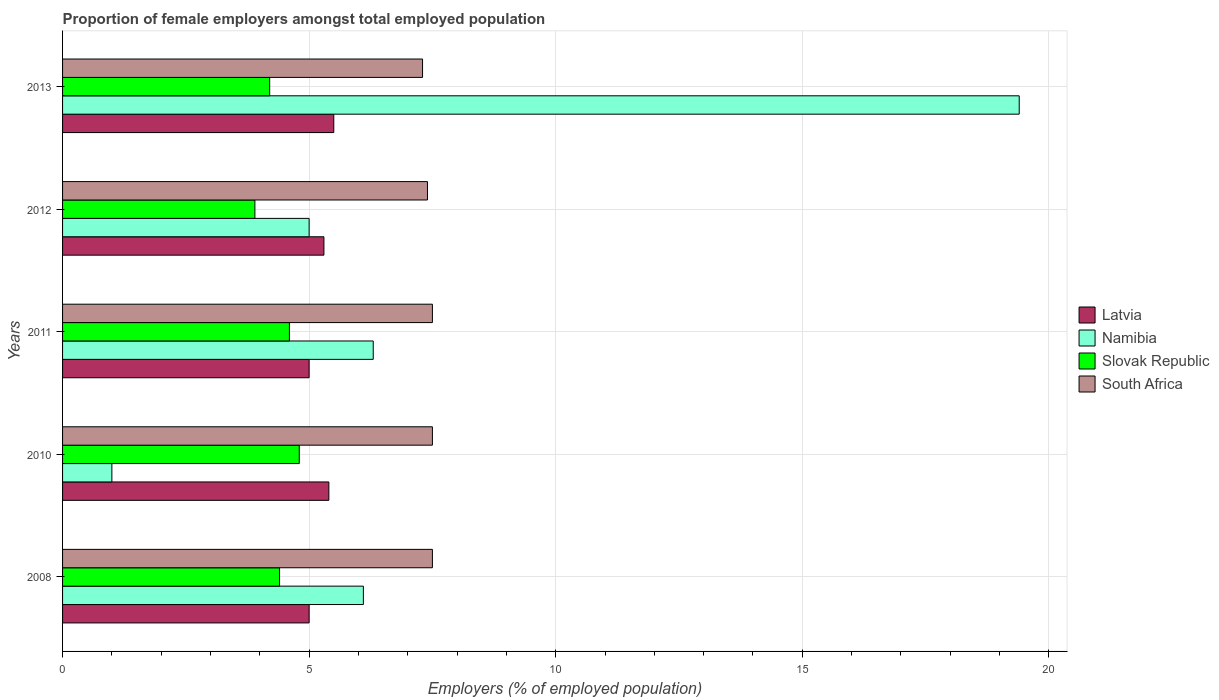How many groups of bars are there?
Provide a succinct answer. 5. Are the number of bars on each tick of the Y-axis equal?
Make the answer very short. Yes. In how many cases, is the number of bars for a given year not equal to the number of legend labels?
Your answer should be very brief. 0. Across all years, what is the minimum proportion of female employers in South Africa?
Provide a short and direct response. 7.3. In which year was the proportion of female employers in Slovak Republic maximum?
Your response must be concise. 2010. In which year was the proportion of female employers in South Africa minimum?
Offer a very short reply. 2013. What is the total proportion of female employers in Namibia in the graph?
Keep it short and to the point. 37.8. What is the difference between the proportion of female employers in Latvia in 2008 and that in 2012?
Your answer should be compact. -0.3. What is the difference between the proportion of female employers in Namibia in 2008 and the proportion of female employers in Slovak Republic in 2012?
Your answer should be very brief. 2.2. What is the average proportion of female employers in Namibia per year?
Offer a very short reply. 7.56. In the year 2010, what is the difference between the proportion of female employers in Slovak Republic and proportion of female employers in South Africa?
Provide a succinct answer. -2.7. What is the ratio of the proportion of female employers in South Africa in 2010 to that in 2013?
Offer a very short reply. 1.03. Is the proportion of female employers in South Africa in 2008 less than that in 2013?
Offer a terse response. No. What is the difference between the highest and the second highest proportion of female employers in Namibia?
Your answer should be very brief. 13.1. What is the difference between the highest and the lowest proportion of female employers in South Africa?
Your answer should be very brief. 0.2. In how many years, is the proportion of female employers in Slovak Republic greater than the average proportion of female employers in Slovak Republic taken over all years?
Your answer should be compact. 3. Is the sum of the proportion of female employers in Slovak Republic in 2008 and 2013 greater than the maximum proportion of female employers in Namibia across all years?
Your answer should be very brief. No. Is it the case that in every year, the sum of the proportion of female employers in Slovak Republic and proportion of female employers in Namibia is greater than the sum of proportion of female employers in South Africa and proportion of female employers in Latvia?
Make the answer very short. No. What does the 1st bar from the top in 2010 represents?
Provide a short and direct response. South Africa. What does the 3rd bar from the bottom in 2012 represents?
Your answer should be compact. Slovak Republic. Is it the case that in every year, the sum of the proportion of female employers in South Africa and proportion of female employers in Latvia is greater than the proportion of female employers in Namibia?
Your response must be concise. No. Are all the bars in the graph horizontal?
Keep it short and to the point. Yes. How many years are there in the graph?
Your answer should be compact. 5. What is the difference between two consecutive major ticks on the X-axis?
Your answer should be compact. 5. Does the graph contain any zero values?
Offer a terse response. No. How are the legend labels stacked?
Your answer should be very brief. Vertical. What is the title of the graph?
Give a very brief answer. Proportion of female employers amongst total employed population. Does "Gabon" appear as one of the legend labels in the graph?
Provide a succinct answer. No. What is the label or title of the X-axis?
Provide a succinct answer. Employers (% of employed population). What is the label or title of the Y-axis?
Provide a short and direct response. Years. What is the Employers (% of employed population) of Latvia in 2008?
Offer a terse response. 5. What is the Employers (% of employed population) in Namibia in 2008?
Your answer should be very brief. 6.1. What is the Employers (% of employed population) in Slovak Republic in 2008?
Provide a succinct answer. 4.4. What is the Employers (% of employed population) in South Africa in 2008?
Provide a short and direct response. 7.5. What is the Employers (% of employed population) in Latvia in 2010?
Your response must be concise. 5.4. What is the Employers (% of employed population) in Slovak Republic in 2010?
Offer a very short reply. 4.8. What is the Employers (% of employed population) in Namibia in 2011?
Your answer should be compact. 6.3. What is the Employers (% of employed population) of Slovak Republic in 2011?
Provide a succinct answer. 4.6. What is the Employers (% of employed population) in South Africa in 2011?
Ensure brevity in your answer.  7.5. What is the Employers (% of employed population) of Latvia in 2012?
Offer a very short reply. 5.3. What is the Employers (% of employed population) in Namibia in 2012?
Provide a succinct answer. 5. What is the Employers (% of employed population) of Slovak Republic in 2012?
Provide a short and direct response. 3.9. What is the Employers (% of employed population) in South Africa in 2012?
Make the answer very short. 7.4. What is the Employers (% of employed population) of Latvia in 2013?
Your response must be concise. 5.5. What is the Employers (% of employed population) in Namibia in 2013?
Your answer should be very brief. 19.4. What is the Employers (% of employed population) in Slovak Republic in 2013?
Provide a succinct answer. 4.2. What is the Employers (% of employed population) of South Africa in 2013?
Make the answer very short. 7.3. Across all years, what is the maximum Employers (% of employed population) of Latvia?
Offer a terse response. 5.5. Across all years, what is the maximum Employers (% of employed population) in Namibia?
Offer a terse response. 19.4. Across all years, what is the maximum Employers (% of employed population) in Slovak Republic?
Give a very brief answer. 4.8. Across all years, what is the minimum Employers (% of employed population) in Slovak Republic?
Ensure brevity in your answer.  3.9. Across all years, what is the minimum Employers (% of employed population) of South Africa?
Your answer should be compact. 7.3. What is the total Employers (% of employed population) of Latvia in the graph?
Give a very brief answer. 26.2. What is the total Employers (% of employed population) of Namibia in the graph?
Provide a succinct answer. 37.8. What is the total Employers (% of employed population) of Slovak Republic in the graph?
Your answer should be compact. 21.9. What is the total Employers (% of employed population) of South Africa in the graph?
Give a very brief answer. 37.2. What is the difference between the Employers (% of employed population) in Latvia in 2008 and that in 2010?
Give a very brief answer. -0.4. What is the difference between the Employers (% of employed population) of Namibia in 2008 and that in 2011?
Provide a short and direct response. -0.2. What is the difference between the Employers (% of employed population) of Slovak Republic in 2008 and that in 2011?
Provide a succinct answer. -0.2. What is the difference between the Employers (% of employed population) in South Africa in 2008 and that in 2011?
Your response must be concise. 0. What is the difference between the Employers (% of employed population) in Latvia in 2008 and that in 2012?
Keep it short and to the point. -0.3. What is the difference between the Employers (% of employed population) of Namibia in 2008 and that in 2012?
Keep it short and to the point. 1.1. What is the difference between the Employers (% of employed population) of Slovak Republic in 2008 and that in 2012?
Offer a very short reply. 0.5. What is the difference between the Employers (% of employed population) in South Africa in 2008 and that in 2012?
Offer a terse response. 0.1. What is the difference between the Employers (% of employed population) in Namibia in 2008 and that in 2013?
Your answer should be very brief. -13.3. What is the difference between the Employers (% of employed population) in South Africa in 2008 and that in 2013?
Give a very brief answer. 0.2. What is the difference between the Employers (% of employed population) of Latvia in 2010 and that in 2011?
Your answer should be compact. 0.4. What is the difference between the Employers (% of employed population) in Namibia in 2010 and that in 2011?
Give a very brief answer. -5.3. What is the difference between the Employers (% of employed population) in Slovak Republic in 2010 and that in 2011?
Offer a terse response. 0.2. What is the difference between the Employers (% of employed population) of South Africa in 2010 and that in 2011?
Offer a terse response. 0. What is the difference between the Employers (% of employed population) of Namibia in 2010 and that in 2012?
Your answer should be compact. -4. What is the difference between the Employers (% of employed population) in Slovak Republic in 2010 and that in 2012?
Provide a succinct answer. 0.9. What is the difference between the Employers (% of employed population) of South Africa in 2010 and that in 2012?
Provide a short and direct response. 0.1. What is the difference between the Employers (% of employed population) in Latvia in 2010 and that in 2013?
Ensure brevity in your answer.  -0.1. What is the difference between the Employers (% of employed population) in Namibia in 2010 and that in 2013?
Make the answer very short. -18.4. What is the difference between the Employers (% of employed population) of Slovak Republic in 2010 and that in 2013?
Your response must be concise. 0.6. What is the difference between the Employers (% of employed population) in Namibia in 2011 and that in 2012?
Offer a very short reply. 1.3. What is the difference between the Employers (% of employed population) in Slovak Republic in 2011 and that in 2013?
Make the answer very short. 0.4. What is the difference between the Employers (% of employed population) of Latvia in 2012 and that in 2013?
Your answer should be very brief. -0.2. What is the difference between the Employers (% of employed population) of Namibia in 2012 and that in 2013?
Your answer should be very brief. -14.4. What is the difference between the Employers (% of employed population) of Latvia in 2008 and the Employers (% of employed population) of Slovak Republic in 2010?
Your response must be concise. 0.2. What is the difference between the Employers (% of employed population) in Namibia in 2008 and the Employers (% of employed population) in Slovak Republic in 2010?
Make the answer very short. 1.3. What is the difference between the Employers (% of employed population) in Namibia in 2008 and the Employers (% of employed population) in South Africa in 2010?
Offer a very short reply. -1.4. What is the difference between the Employers (% of employed population) of Latvia in 2008 and the Employers (% of employed population) of Namibia in 2011?
Your answer should be very brief. -1.3. What is the difference between the Employers (% of employed population) in Latvia in 2008 and the Employers (% of employed population) in South Africa in 2011?
Your answer should be very brief. -2.5. What is the difference between the Employers (% of employed population) of Namibia in 2008 and the Employers (% of employed population) of Slovak Republic in 2011?
Offer a terse response. 1.5. What is the difference between the Employers (% of employed population) in Namibia in 2008 and the Employers (% of employed population) in South Africa in 2011?
Make the answer very short. -1.4. What is the difference between the Employers (% of employed population) in Slovak Republic in 2008 and the Employers (% of employed population) in South Africa in 2011?
Make the answer very short. -3.1. What is the difference between the Employers (% of employed population) of Latvia in 2008 and the Employers (% of employed population) of Namibia in 2012?
Offer a very short reply. 0. What is the difference between the Employers (% of employed population) of Latvia in 2008 and the Employers (% of employed population) of Slovak Republic in 2012?
Offer a very short reply. 1.1. What is the difference between the Employers (% of employed population) of Namibia in 2008 and the Employers (% of employed population) of Slovak Republic in 2012?
Your answer should be very brief. 2.2. What is the difference between the Employers (% of employed population) in Namibia in 2008 and the Employers (% of employed population) in South Africa in 2012?
Keep it short and to the point. -1.3. What is the difference between the Employers (% of employed population) in Latvia in 2008 and the Employers (% of employed population) in Namibia in 2013?
Offer a terse response. -14.4. What is the difference between the Employers (% of employed population) of Slovak Republic in 2008 and the Employers (% of employed population) of South Africa in 2013?
Offer a very short reply. -2.9. What is the difference between the Employers (% of employed population) in Latvia in 2010 and the Employers (% of employed population) in Namibia in 2011?
Provide a short and direct response. -0.9. What is the difference between the Employers (% of employed population) in Latvia in 2010 and the Employers (% of employed population) in Slovak Republic in 2011?
Offer a terse response. 0.8. What is the difference between the Employers (% of employed population) in Namibia in 2010 and the Employers (% of employed population) in Slovak Republic in 2011?
Provide a succinct answer. -3.6. What is the difference between the Employers (% of employed population) of Latvia in 2010 and the Employers (% of employed population) of South Africa in 2012?
Your response must be concise. -2. What is the difference between the Employers (% of employed population) of Latvia in 2010 and the Employers (% of employed population) of Slovak Republic in 2013?
Keep it short and to the point. 1.2. What is the difference between the Employers (% of employed population) in Latvia in 2010 and the Employers (% of employed population) in South Africa in 2013?
Give a very brief answer. -1.9. What is the difference between the Employers (% of employed population) of Slovak Republic in 2010 and the Employers (% of employed population) of South Africa in 2013?
Offer a terse response. -2.5. What is the difference between the Employers (% of employed population) in Latvia in 2011 and the Employers (% of employed population) in Namibia in 2012?
Ensure brevity in your answer.  0. What is the difference between the Employers (% of employed population) of Latvia in 2011 and the Employers (% of employed population) of Namibia in 2013?
Give a very brief answer. -14.4. What is the difference between the Employers (% of employed population) in Latvia in 2011 and the Employers (% of employed population) in South Africa in 2013?
Give a very brief answer. -2.3. What is the difference between the Employers (% of employed population) of Namibia in 2011 and the Employers (% of employed population) of Slovak Republic in 2013?
Provide a succinct answer. 2.1. What is the difference between the Employers (% of employed population) in Namibia in 2011 and the Employers (% of employed population) in South Africa in 2013?
Your answer should be compact. -1. What is the difference between the Employers (% of employed population) of Latvia in 2012 and the Employers (% of employed population) of Namibia in 2013?
Ensure brevity in your answer.  -14.1. What is the difference between the Employers (% of employed population) of Latvia in 2012 and the Employers (% of employed population) of Slovak Republic in 2013?
Keep it short and to the point. 1.1. What is the difference between the Employers (% of employed population) in Latvia in 2012 and the Employers (% of employed population) in South Africa in 2013?
Offer a very short reply. -2. What is the difference between the Employers (% of employed population) in Namibia in 2012 and the Employers (% of employed population) in Slovak Republic in 2013?
Ensure brevity in your answer.  0.8. What is the difference between the Employers (% of employed population) of Slovak Republic in 2012 and the Employers (% of employed population) of South Africa in 2013?
Keep it short and to the point. -3.4. What is the average Employers (% of employed population) in Latvia per year?
Provide a short and direct response. 5.24. What is the average Employers (% of employed population) of Namibia per year?
Ensure brevity in your answer.  7.56. What is the average Employers (% of employed population) of Slovak Republic per year?
Make the answer very short. 4.38. What is the average Employers (% of employed population) of South Africa per year?
Provide a succinct answer. 7.44. In the year 2008, what is the difference between the Employers (% of employed population) in Latvia and Employers (% of employed population) in Namibia?
Give a very brief answer. -1.1. In the year 2008, what is the difference between the Employers (% of employed population) in Latvia and Employers (% of employed population) in Slovak Republic?
Keep it short and to the point. 0.6. In the year 2008, what is the difference between the Employers (% of employed population) of Namibia and Employers (% of employed population) of Slovak Republic?
Your response must be concise. 1.7. In the year 2008, what is the difference between the Employers (% of employed population) in Namibia and Employers (% of employed population) in South Africa?
Your answer should be very brief. -1.4. In the year 2008, what is the difference between the Employers (% of employed population) of Slovak Republic and Employers (% of employed population) of South Africa?
Offer a terse response. -3.1. In the year 2010, what is the difference between the Employers (% of employed population) in Latvia and Employers (% of employed population) in South Africa?
Provide a short and direct response. -2.1. In the year 2010, what is the difference between the Employers (% of employed population) of Namibia and Employers (% of employed population) of South Africa?
Make the answer very short. -6.5. In the year 2010, what is the difference between the Employers (% of employed population) of Slovak Republic and Employers (% of employed population) of South Africa?
Provide a succinct answer. -2.7. In the year 2011, what is the difference between the Employers (% of employed population) of Latvia and Employers (% of employed population) of Slovak Republic?
Your answer should be very brief. 0.4. In the year 2011, what is the difference between the Employers (% of employed population) of Latvia and Employers (% of employed population) of South Africa?
Make the answer very short. -2.5. In the year 2011, what is the difference between the Employers (% of employed population) of Namibia and Employers (% of employed population) of Slovak Republic?
Your answer should be very brief. 1.7. In the year 2011, what is the difference between the Employers (% of employed population) in Namibia and Employers (% of employed population) in South Africa?
Make the answer very short. -1.2. In the year 2011, what is the difference between the Employers (% of employed population) of Slovak Republic and Employers (% of employed population) of South Africa?
Give a very brief answer. -2.9. In the year 2012, what is the difference between the Employers (% of employed population) in Slovak Republic and Employers (% of employed population) in South Africa?
Your answer should be compact. -3.5. In the year 2013, what is the difference between the Employers (% of employed population) in Latvia and Employers (% of employed population) in Namibia?
Your answer should be very brief. -13.9. In the year 2013, what is the difference between the Employers (% of employed population) in Latvia and Employers (% of employed population) in Slovak Republic?
Make the answer very short. 1.3. In the year 2013, what is the difference between the Employers (% of employed population) of Latvia and Employers (% of employed population) of South Africa?
Your response must be concise. -1.8. In the year 2013, what is the difference between the Employers (% of employed population) in Slovak Republic and Employers (% of employed population) in South Africa?
Offer a terse response. -3.1. What is the ratio of the Employers (% of employed population) in Latvia in 2008 to that in 2010?
Your response must be concise. 0.93. What is the ratio of the Employers (% of employed population) in Namibia in 2008 to that in 2010?
Give a very brief answer. 6.1. What is the ratio of the Employers (% of employed population) in Latvia in 2008 to that in 2011?
Offer a terse response. 1. What is the ratio of the Employers (% of employed population) of Namibia in 2008 to that in 2011?
Give a very brief answer. 0.97. What is the ratio of the Employers (% of employed population) in Slovak Republic in 2008 to that in 2011?
Your answer should be compact. 0.96. What is the ratio of the Employers (% of employed population) of Latvia in 2008 to that in 2012?
Ensure brevity in your answer.  0.94. What is the ratio of the Employers (% of employed population) of Namibia in 2008 to that in 2012?
Offer a terse response. 1.22. What is the ratio of the Employers (% of employed population) in Slovak Republic in 2008 to that in 2012?
Your answer should be compact. 1.13. What is the ratio of the Employers (% of employed population) in South Africa in 2008 to that in 2012?
Make the answer very short. 1.01. What is the ratio of the Employers (% of employed population) in Namibia in 2008 to that in 2013?
Keep it short and to the point. 0.31. What is the ratio of the Employers (% of employed population) in Slovak Republic in 2008 to that in 2013?
Offer a very short reply. 1.05. What is the ratio of the Employers (% of employed population) in South Africa in 2008 to that in 2013?
Ensure brevity in your answer.  1.03. What is the ratio of the Employers (% of employed population) of Latvia in 2010 to that in 2011?
Keep it short and to the point. 1.08. What is the ratio of the Employers (% of employed population) in Namibia in 2010 to that in 2011?
Offer a very short reply. 0.16. What is the ratio of the Employers (% of employed population) in Slovak Republic in 2010 to that in 2011?
Provide a short and direct response. 1.04. What is the ratio of the Employers (% of employed population) of Latvia in 2010 to that in 2012?
Provide a succinct answer. 1.02. What is the ratio of the Employers (% of employed population) in Namibia in 2010 to that in 2012?
Provide a short and direct response. 0.2. What is the ratio of the Employers (% of employed population) of Slovak Republic in 2010 to that in 2012?
Provide a short and direct response. 1.23. What is the ratio of the Employers (% of employed population) in South Africa in 2010 to that in 2012?
Keep it short and to the point. 1.01. What is the ratio of the Employers (% of employed population) in Latvia in 2010 to that in 2013?
Provide a succinct answer. 0.98. What is the ratio of the Employers (% of employed population) in Namibia in 2010 to that in 2013?
Make the answer very short. 0.05. What is the ratio of the Employers (% of employed population) in Slovak Republic in 2010 to that in 2013?
Provide a succinct answer. 1.14. What is the ratio of the Employers (% of employed population) of South Africa in 2010 to that in 2013?
Provide a succinct answer. 1.03. What is the ratio of the Employers (% of employed population) in Latvia in 2011 to that in 2012?
Provide a short and direct response. 0.94. What is the ratio of the Employers (% of employed population) in Namibia in 2011 to that in 2012?
Your response must be concise. 1.26. What is the ratio of the Employers (% of employed population) in Slovak Republic in 2011 to that in 2012?
Provide a succinct answer. 1.18. What is the ratio of the Employers (% of employed population) in South Africa in 2011 to that in 2012?
Your answer should be compact. 1.01. What is the ratio of the Employers (% of employed population) of Namibia in 2011 to that in 2013?
Your response must be concise. 0.32. What is the ratio of the Employers (% of employed population) of Slovak Republic in 2011 to that in 2013?
Make the answer very short. 1.1. What is the ratio of the Employers (% of employed population) of South Africa in 2011 to that in 2013?
Ensure brevity in your answer.  1.03. What is the ratio of the Employers (% of employed population) of Latvia in 2012 to that in 2013?
Offer a terse response. 0.96. What is the ratio of the Employers (% of employed population) of Namibia in 2012 to that in 2013?
Offer a terse response. 0.26. What is the ratio of the Employers (% of employed population) in South Africa in 2012 to that in 2013?
Provide a short and direct response. 1.01. What is the difference between the highest and the second highest Employers (% of employed population) of Namibia?
Make the answer very short. 13.1. What is the difference between the highest and the lowest Employers (% of employed population) of Latvia?
Your answer should be compact. 0.5. What is the difference between the highest and the lowest Employers (% of employed population) of South Africa?
Ensure brevity in your answer.  0.2. 